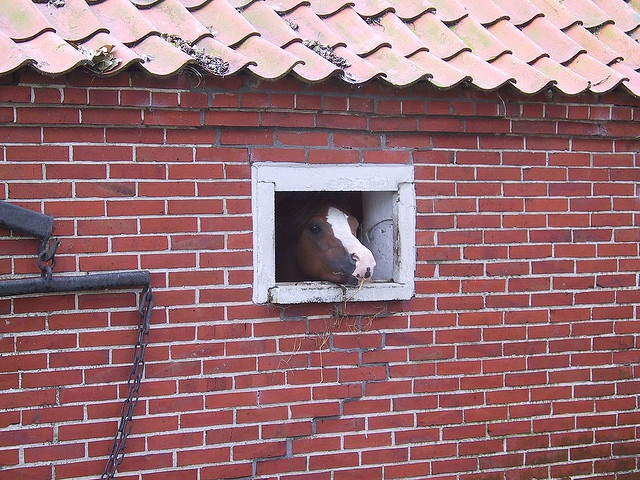Describe the objects in this image and their specific colors. I can see a horse in lightgray, black, gray, and lavender tones in this image. 